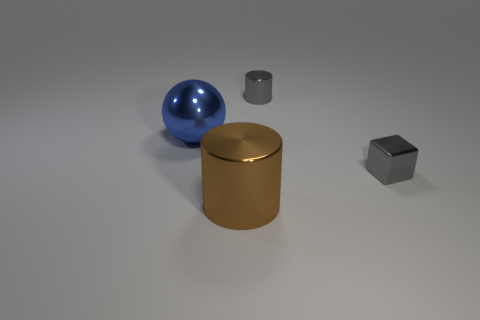Add 3 brown cylinders. How many objects exist? 7 Subtract all blocks. How many objects are left? 3 Add 4 brown things. How many brown things are left? 5 Add 2 big blue metallic objects. How many big blue metallic objects exist? 3 Subtract 0 green spheres. How many objects are left? 4 Subtract all gray cylinders. Subtract all big cylinders. How many objects are left? 2 